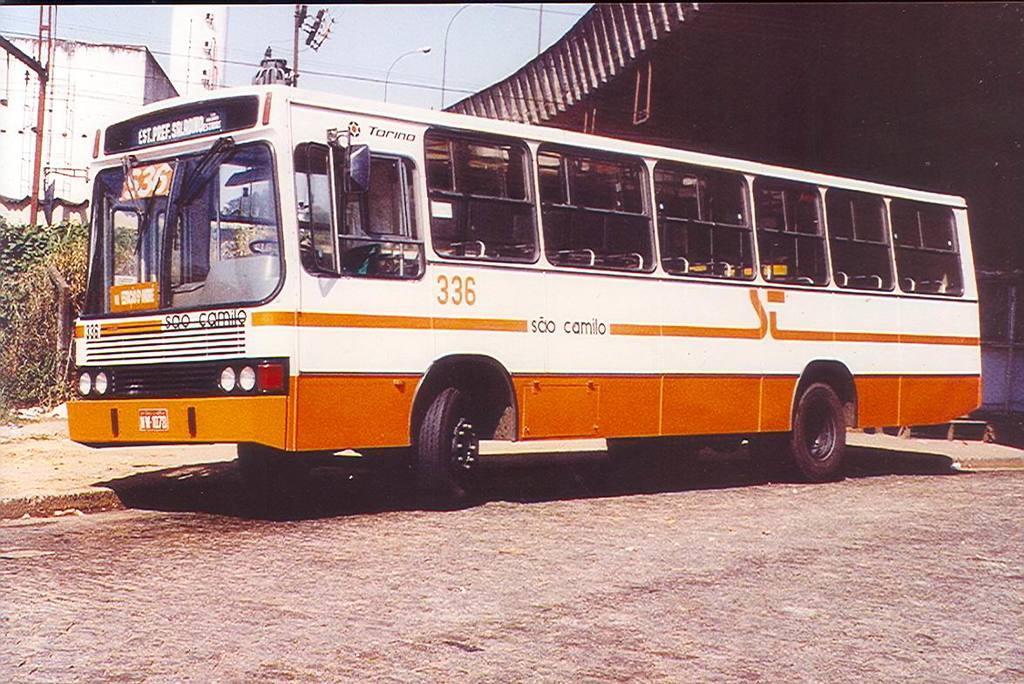In one or two sentences, can you explain what this image depicts? There is a bus in white and orange color combination having windows on the road. In the background, there are poles, a building, a tower, a shelter and there is sky. 